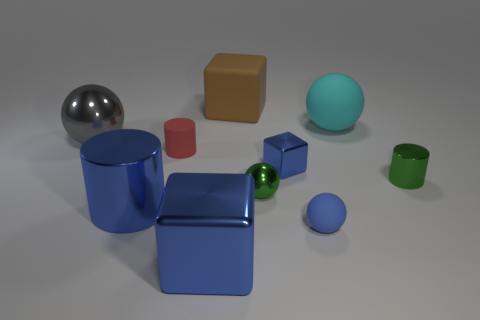There is a tiny object that is the same color as the small shiny sphere; what is its shape?
Provide a succinct answer. Cylinder. Is the size of the gray shiny thing the same as the rubber sphere behind the tiny blue rubber ball?
Ensure brevity in your answer.  Yes. There is a matte sphere that is behind the small ball behind the metallic cylinder to the left of the tiny red cylinder; what is its size?
Your response must be concise. Large. How big is the block behind the red matte cylinder?
Your answer should be compact. Large. What shape is the large gray object that is made of the same material as the small cube?
Your answer should be compact. Sphere. Does the tiny sphere in front of the big blue shiny cylinder have the same material as the big gray thing?
Give a very brief answer. No. How many other things are the same material as the red cylinder?
Offer a very short reply. 3. What number of things are either large blue things that are on the left side of the tiny red object or small metallic objects that are to the left of the big cyan ball?
Offer a terse response. 3. There is a rubber object left of the big blue metallic block; is it the same shape as the blue rubber thing right of the big brown block?
Keep it short and to the point. No. What is the shape of the gray metal object that is the same size as the rubber block?
Your answer should be very brief. Sphere. 